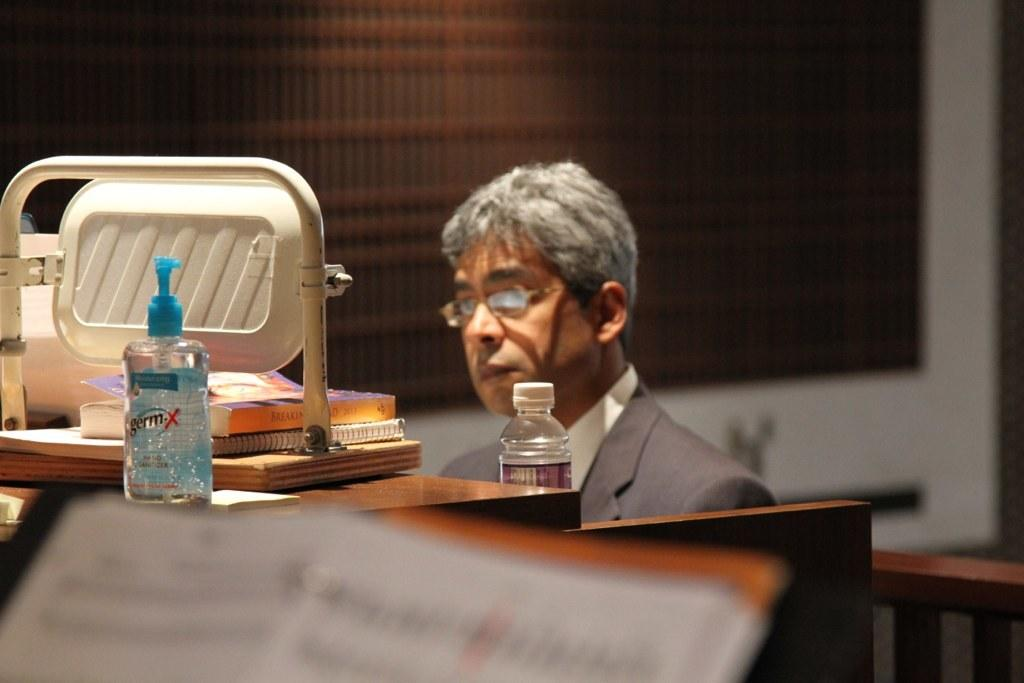Provide a one-sentence caption for the provided image. Man sitting behind a desk with a germ-X on top. 